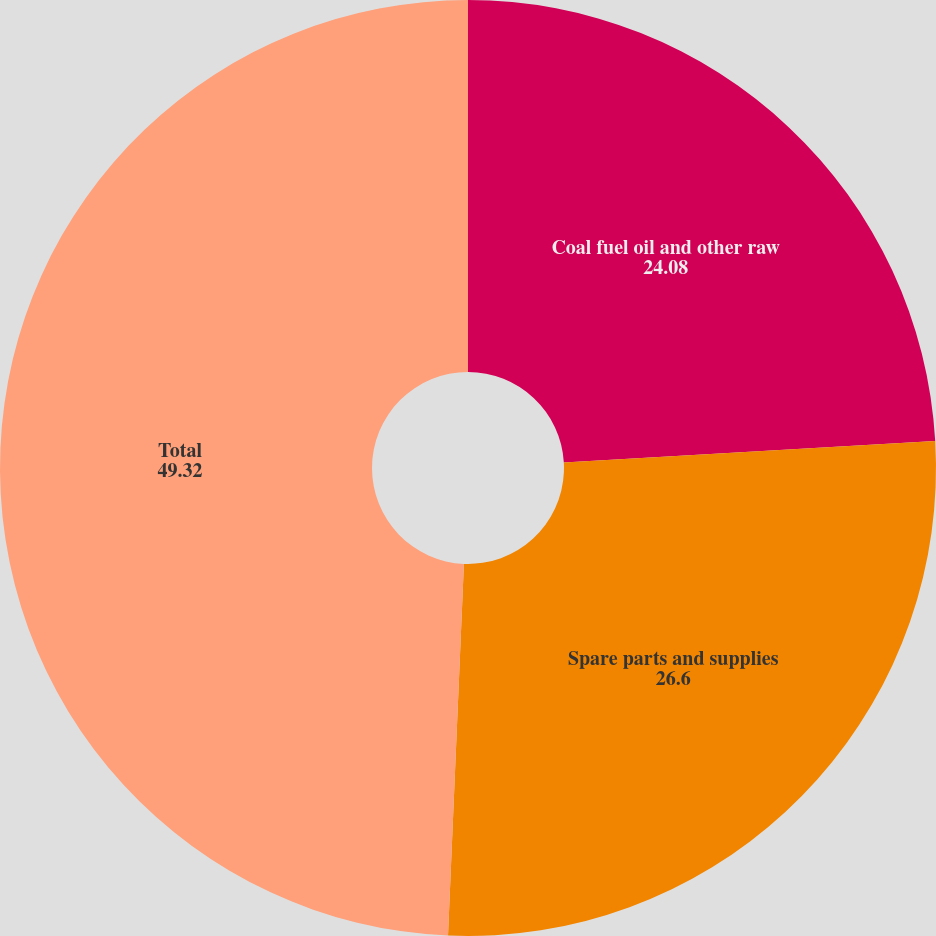Convert chart to OTSL. <chart><loc_0><loc_0><loc_500><loc_500><pie_chart><fcel>Coal fuel oil and other raw<fcel>Spare parts and supplies<fcel>Total<nl><fcel>24.08%<fcel>26.6%<fcel>49.32%<nl></chart> 